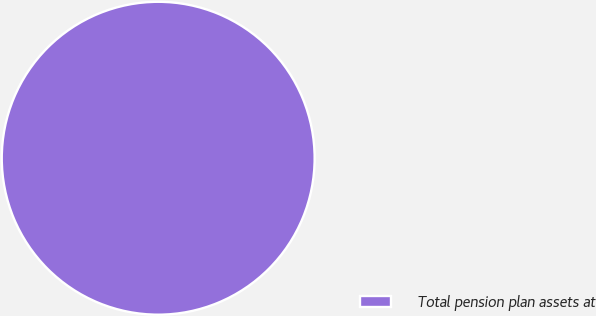<chart> <loc_0><loc_0><loc_500><loc_500><pie_chart><fcel>Total pension plan assets at<nl><fcel>100.0%<nl></chart> 